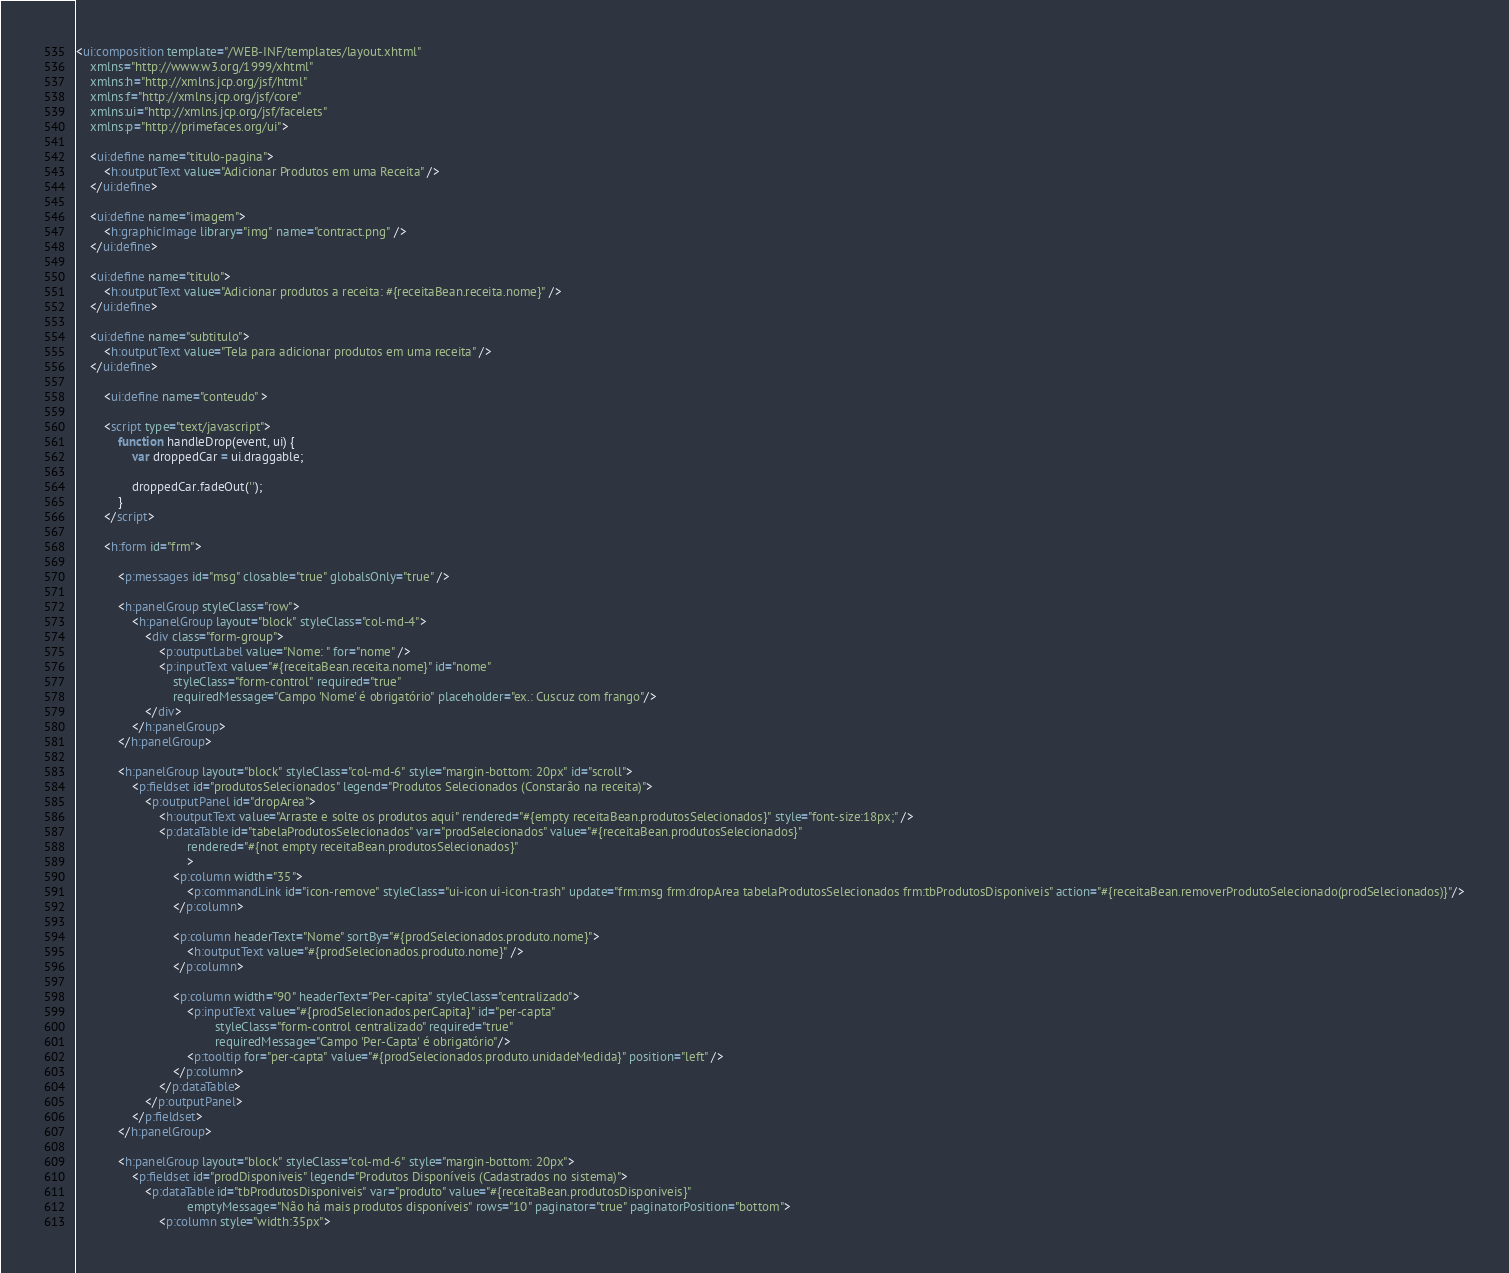<code> <loc_0><loc_0><loc_500><loc_500><_HTML_><ui:composition template="/WEB-INF/templates/layout.xhtml"
	xmlns="http://www.w3.org/1999/xhtml"
	xmlns:h="http://xmlns.jcp.org/jsf/html"
	xmlns:f="http://xmlns.jcp.org/jsf/core"
	xmlns:ui="http://xmlns.jcp.org/jsf/facelets"
	xmlns:p="http://primefaces.org/ui">

	<ui:define name="titulo-pagina">
		<h:outputText value="Adicionar Produtos em uma Receita" />
	</ui:define>

	<ui:define name="imagem">
		<h:graphicImage library="img" name="contract.png" />
	</ui:define>

	<ui:define name="titulo">
		<h:outputText value="Adicionar produtos a receita: #{receitaBean.receita.nome}" />
	</ui:define>

	<ui:define name="subtitulo">
		<h:outputText value="Tela para adicionar produtos em uma receita" />
	</ui:define>
		
		<ui:define name="conteudo" >
	
		<script type="text/javascript">
		    function handleDrop(event, ui) {
		        var droppedCar = ui.draggable;
		 
		        droppedCar.fadeOut('');
		    }
		</script>
	
		<h:form id="frm">
		
			<p:messages id="msg" closable="true" globalsOnly="true" />
			
			<h:panelGroup styleClass="row">
				<h:panelGroup layout="block" styleClass="col-md-4">
					<div class="form-group">
						<p:outputLabel value="Nome: " for="nome" />
						<p:inputText value="#{receitaBean.receita.nome}" id="nome"
							styleClass="form-control" required="true"
							requiredMessage="Campo 'Nome' é obrigatório" placeholder="ex.: Cuscuz com frango"/>
					</div>
				</h:panelGroup>
			</h:panelGroup>
			
			<h:panelGroup layout="block" styleClass="col-md-6" style="margin-bottom: 20px" id="scroll">
				<p:fieldset id="produtosSelecionados" legend="Produtos Selecionados (Constarão na receita)">
			        <p:outputPanel id="dropArea">
			            <h:outputText value="Arraste e solte os produtos aqui" rendered="#{empty receitaBean.produtosSelecionados}" style="font-size:18px;" />
			            <p:dataTable id="tabelaProdutosSelecionados" var="prodSelecionados" value="#{receitaBean.produtosSelecionados}" 
			            		rendered="#{not empty receitaBean.produtosSelecionados}" 
			            		>
			            	<p:column width="35">
			                	<p:commandLink id="icon-remove" styleClass="ui-icon ui-icon-trash" update="frm:msg frm:dropArea tabelaProdutosSelecionados frm:tbProdutosDisponiveis" action="#{receitaBean.removerProdutoSelecionado(prodSelecionados)}"/>
			                </p:column>
			                
			                <p:column headerText="Nome" sortBy="#{prodSelecionados.produto.nome}">
			                    <h:outputText value="#{prodSelecionados.produto.nome}" />
			                </p:column>
			                
			                <p:column width="90" headerText="Per-capita" styleClass="centralizado">
								<p:inputText value="#{prodSelecionados.perCapita}" id="per-capta" 
										styleClass="form-control centralizado" required="true"
										requiredMessage="Campo 'Per-Capta' é obrigatório"/>
								<p:tooltip for="per-capta" value="#{prodSelecionados.produto.unidadeMedida}" position="left" />
			                </p:column>
			            </p:dataTable>
			        </p:outputPanel>
			    </p:fieldset>
			</h:panelGroup>
			
			<h:panelGroup layout="block" styleClass="col-md-6" style="margin-bottom: 20px">
				<p:fieldset id="prodDisponiveis" legend="Produtos Disponíveis (Cadastrados no sistema)">
			        <p:dataTable id="tbProdutosDisponiveis" var="produto" value="#{receitaBean.produtosDisponiveis}" 
			        			emptyMessage="Não há mais produtos disponíveis" rows="10" paginator="true" paginatorPosition="bottom">
			            <p:column style="width:35px"></code> 